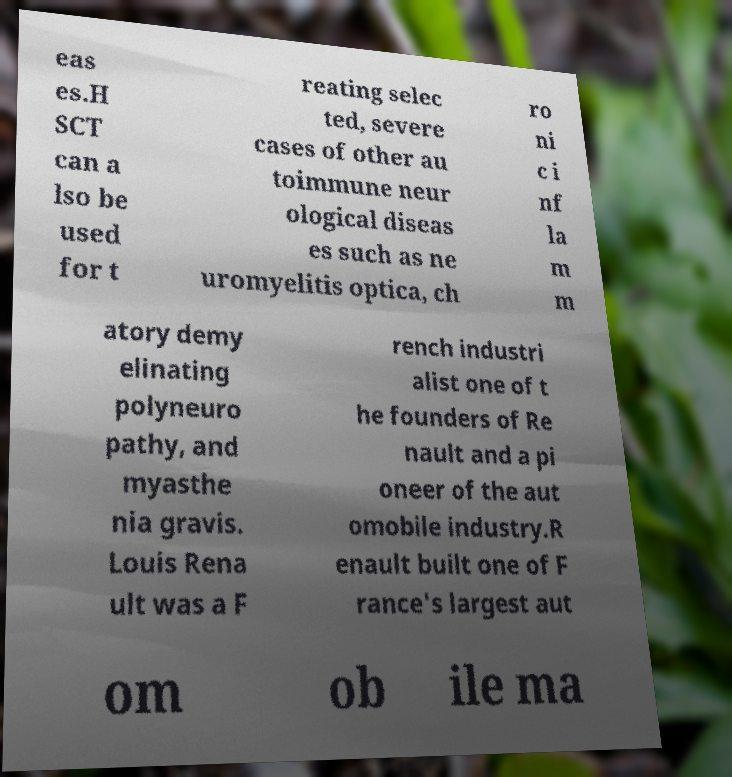Please read and relay the text visible in this image. What does it say? eas es.H SCT can a lso be used for t reating selec ted, severe cases of other au toimmune neur ological diseas es such as ne uromyelitis optica, ch ro ni c i nf la m m atory demy elinating polyneuro pathy, and myasthe nia gravis. Louis Rena ult was a F rench industri alist one of t he founders of Re nault and a pi oneer of the aut omobile industry.R enault built one of F rance's largest aut om ob ile ma 